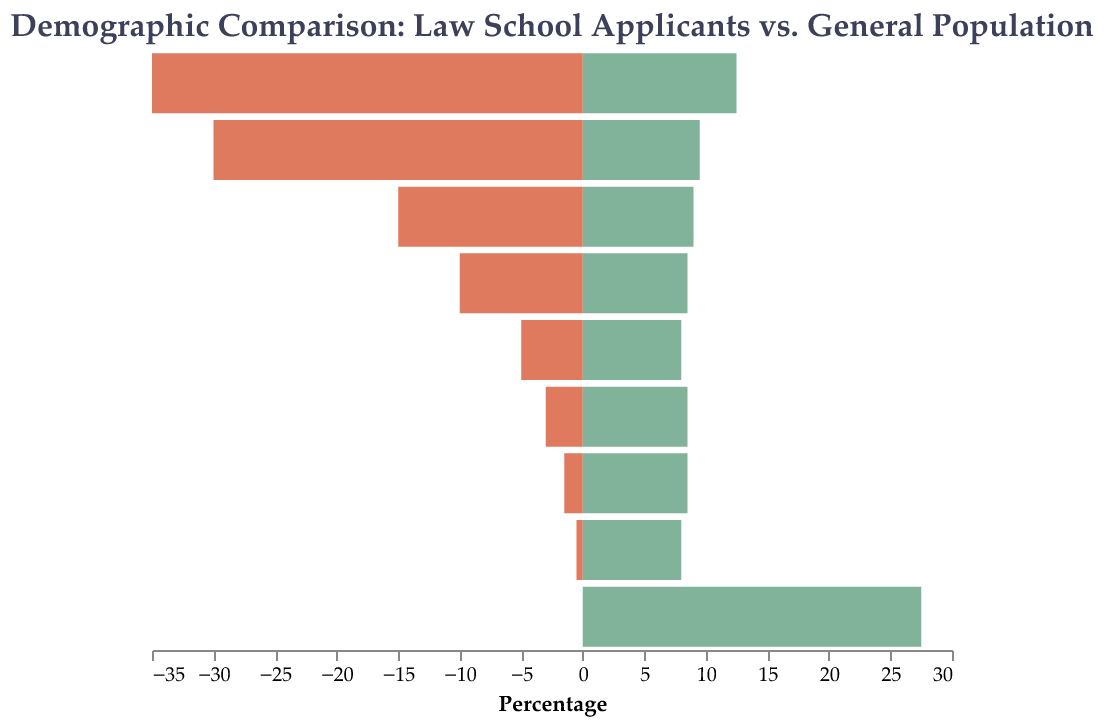What is the age group with the highest percentage of law school applicants? The highest percentage of law school applicants is in the 18-24 age group, which can be identified by comparing the height of the bars on the left side of the plot.
Answer: 18-24 How does the percentage of law school applicants in the 25-29 age group compare to the general population in the same age group? The percentage of law school applicants in the 25-29 age group is 30%, while the percentage in the general population is 9.5%. This can be observed by comparing the two bars corresponding to the 25-29 age group.
Answer: 30% vs. 9.5% Which age group has the largest difference between law school applicants and the general population? The age group 18-24 has the largest difference. The difference can be calculated by subtracting the general population percentage (12.5%) from the law school applicants percentage (35%).
Answer: 18-24 What percentage of the general population is aged 60+? The percentage of the general population aged 60+ is represented by the height of the bar on the right side corresponding to the 60+ age group.
Answer: 27.5% Which age group has a higher percentage in the general population compared to law school applicants? All age groups from 40-44 to 60+ have a higher percentage in the general population compared to law school applicants. This can be observed by comparing the height of the bars on the right versus the left.
Answer: 40-44 to 60+ What is the combined percentage of law school applicants for the age groups 35-39 and 40-44? Add the percentages for law school applicants in the 35-39 group (10%) and 40-44 group (5%).
Answer: 15% At what age group does the percentage of law school applicants drop below 5%? The percentage of law school applicants drops below 5% from age group 45-49 onwards, as seen on the left side of the plot.
Answer: 45-49 What is the trend observed in the percentage of law school applicants as age increases? The trend shows that the percentage of law school applicants decreases as age increases, evident from the diminishing heights of the bars toward older age groups on the left side of the plot.
Answer: Decreases Compare the overall shape of the data distribution for the law school applicants and the general population. The law school applicants' distribution is skewed heavily towards younger age groups, peaking at 18-24 and tapering off rapidly. In contrast, the general population is more evenly distributed across age groups, with a significant peak at 60+.
Answer: Skewed vs. Even Which age group is least represented in law school applicants? The age group 60+ is least represented among law school applicants, as indicated by the bar being at 0% on the left side of the plot.
Answer: 60+ 